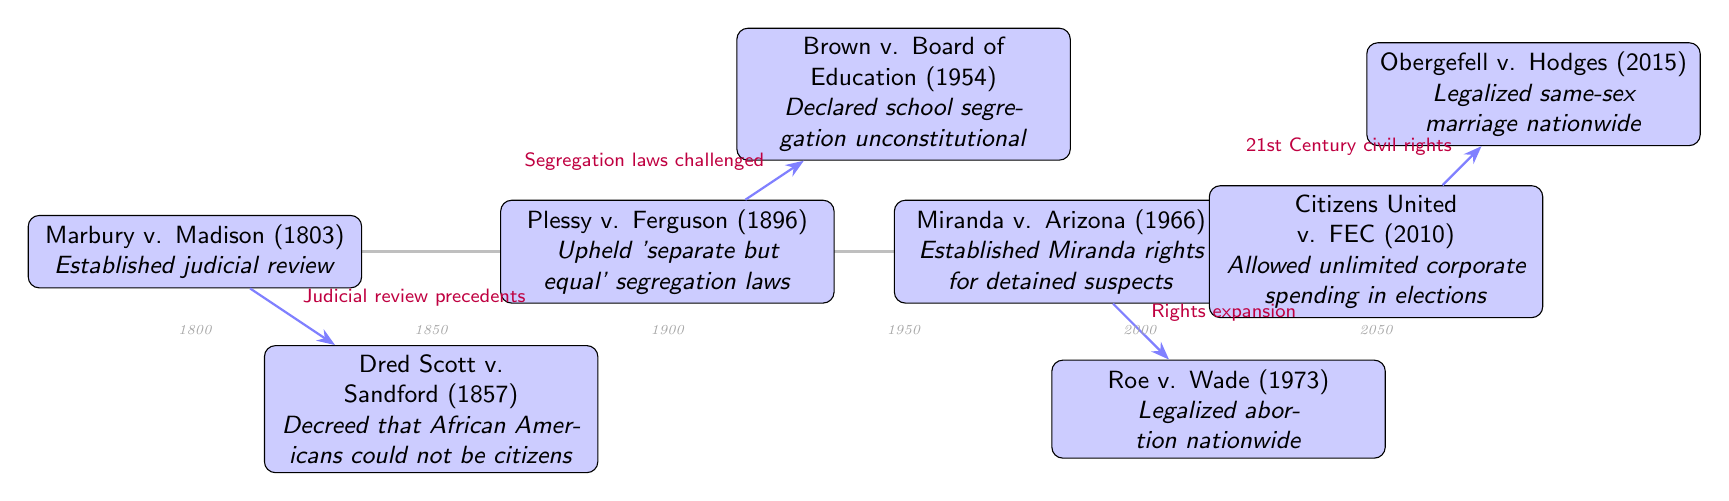What is the outcome of Marbury v. Madison? The diagram indicates that the outcome of Marbury v. Madison is the establishment of judicial review. This can be found in the node detailing the event.
Answer: Establish judicial review What year did Brown v. Board of Education occur? By examining the specific node for Brown v. Board of Education, the diagram reveals that this decision took place in 1954.
Answer: 1954 How many major Supreme Court decisions are represented in the diagram? Counting the nodes in the diagram, we find that there are a total of seven significant Supreme Court decisions, thus confirming the total.
Answer: 7 What legal precedent is linked to Roe v. Wade? The diagram connects Roe v. Wade to rights expansion, as indicated by the arrow labeling the edge between these events.
Answer: Rights expansion Which Supreme Court case legalized same-sex marriage nationwide? Looking at the rightmost node in the diagram, it states that Obergefell v. Hodges is the case that legalized same-sex marriage nationwide.
Answer: Obergefell v. Hodges What is the relationship between Plessy v. Ferguson and Brown v. Board of Education? The diagram shows that Brown v. Board of Education is related to Plessy v. Ferguson through the label "Segregation laws challenged," implying a direct challenge to the previous ruling.
Answer: Segregation laws challenged In what context was Dred Scott v. Sandford mentioned? The diagram mentions that Dred Scott v. Sandford decreed that African Americans could not be citizens, providing the basis for understanding its significance in American legal history.
Answer: Decreed that African Americans could not be citizens What century did Citizens United v. FEC take place in? The timeline indicates that Citizens United v. FEC occurred in the 21st Century, which can be inferred by its year 2010 placement on the diagram.
Answer: 21st Century 